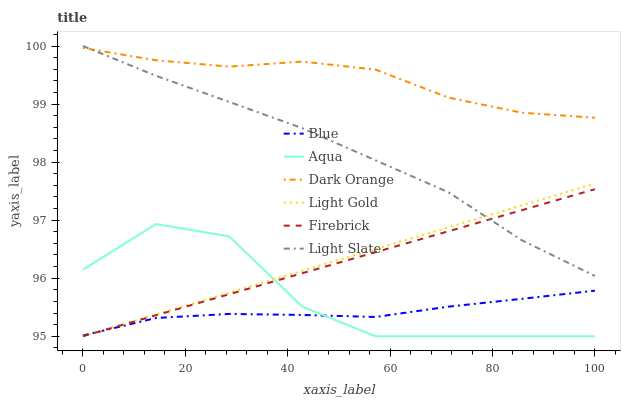Does Blue have the minimum area under the curve?
Answer yes or no. Yes. Does Dark Orange have the maximum area under the curve?
Answer yes or no. Yes. Does Light Slate have the minimum area under the curve?
Answer yes or no. No. Does Light Slate have the maximum area under the curve?
Answer yes or no. No. Is Light Gold the smoothest?
Answer yes or no. Yes. Is Aqua the roughest?
Answer yes or no. Yes. Is Dark Orange the smoothest?
Answer yes or no. No. Is Dark Orange the roughest?
Answer yes or no. No. Does Firebrick have the lowest value?
Answer yes or no. Yes. Does Light Slate have the lowest value?
Answer yes or no. No. Does Light Slate have the highest value?
Answer yes or no. Yes. Does Dark Orange have the highest value?
Answer yes or no. No. Is Firebrick less than Dark Orange?
Answer yes or no. Yes. Is Light Slate greater than Aqua?
Answer yes or no. Yes. Does Light Slate intersect Light Gold?
Answer yes or no. Yes. Is Light Slate less than Light Gold?
Answer yes or no. No. Is Light Slate greater than Light Gold?
Answer yes or no. No. Does Firebrick intersect Dark Orange?
Answer yes or no. No. 